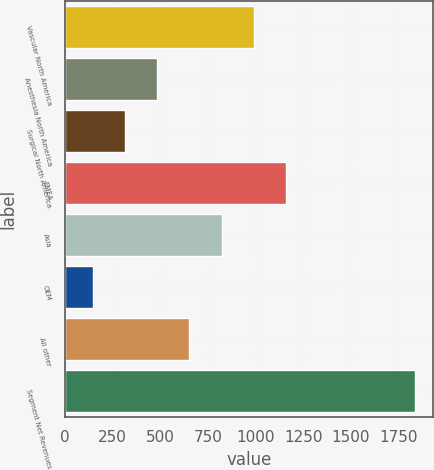<chart> <loc_0><loc_0><loc_500><loc_500><bar_chart><fcel>Vascular North America<fcel>Anesthesia North America<fcel>Surgical North America<fcel>EMEA<fcel>Asia<fcel>OEM<fcel>All other<fcel>Segment Net Revenues<nl><fcel>991.9<fcel>483.16<fcel>313.58<fcel>1161.48<fcel>822.32<fcel>144<fcel>652.74<fcel>1839.8<nl></chart> 